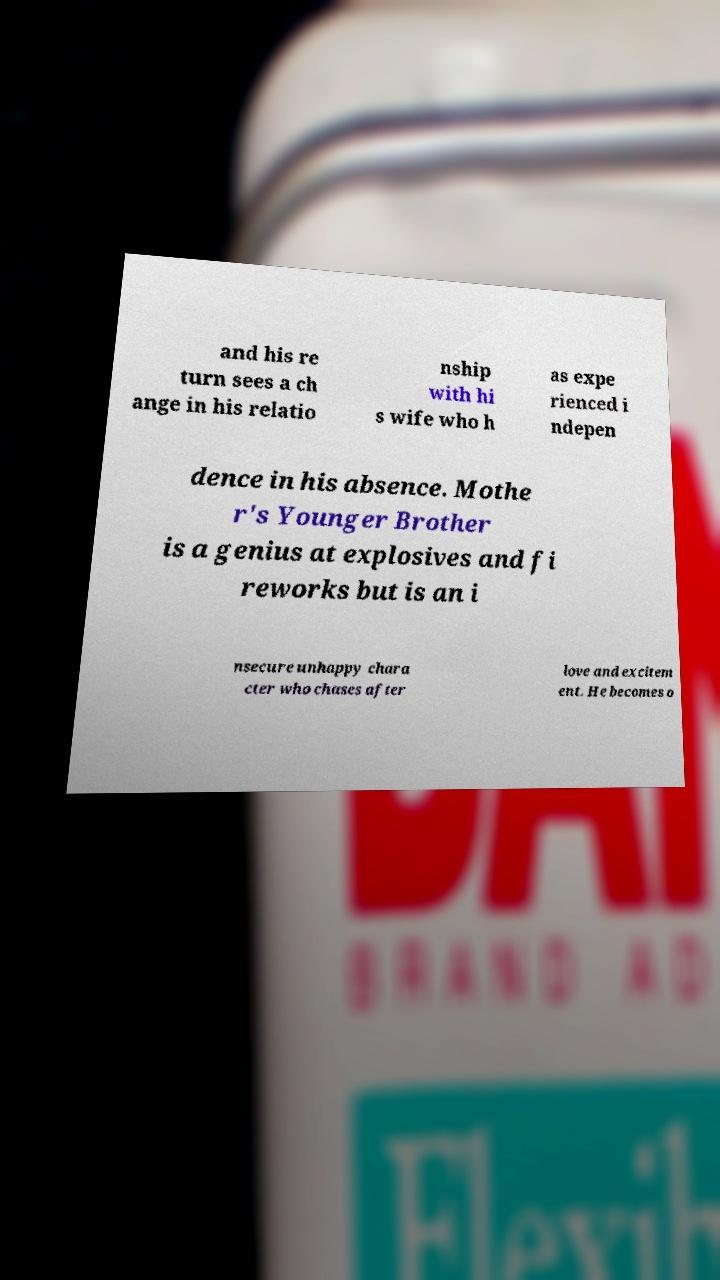I need the written content from this picture converted into text. Can you do that? and his re turn sees a ch ange in his relatio nship with hi s wife who h as expe rienced i ndepen dence in his absence. Mothe r's Younger Brother is a genius at explosives and fi reworks but is an i nsecure unhappy chara cter who chases after love and excitem ent. He becomes o 